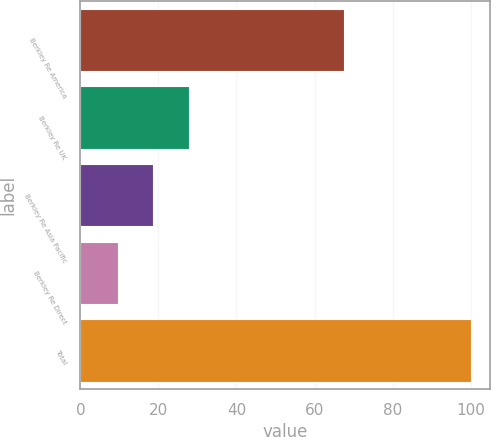Convert chart to OTSL. <chart><loc_0><loc_0><loc_500><loc_500><bar_chart><fcel>Berkley Re America<fcel>Berkley Re UK<fcel>Berkley Re Asia Pacific<fcel>Berkley Re Direct<fcel>Total<nl><fcel>67.6<fcel>27.76<fcel>18.73<fcel>9.7<fcel>100<nl></chart> 